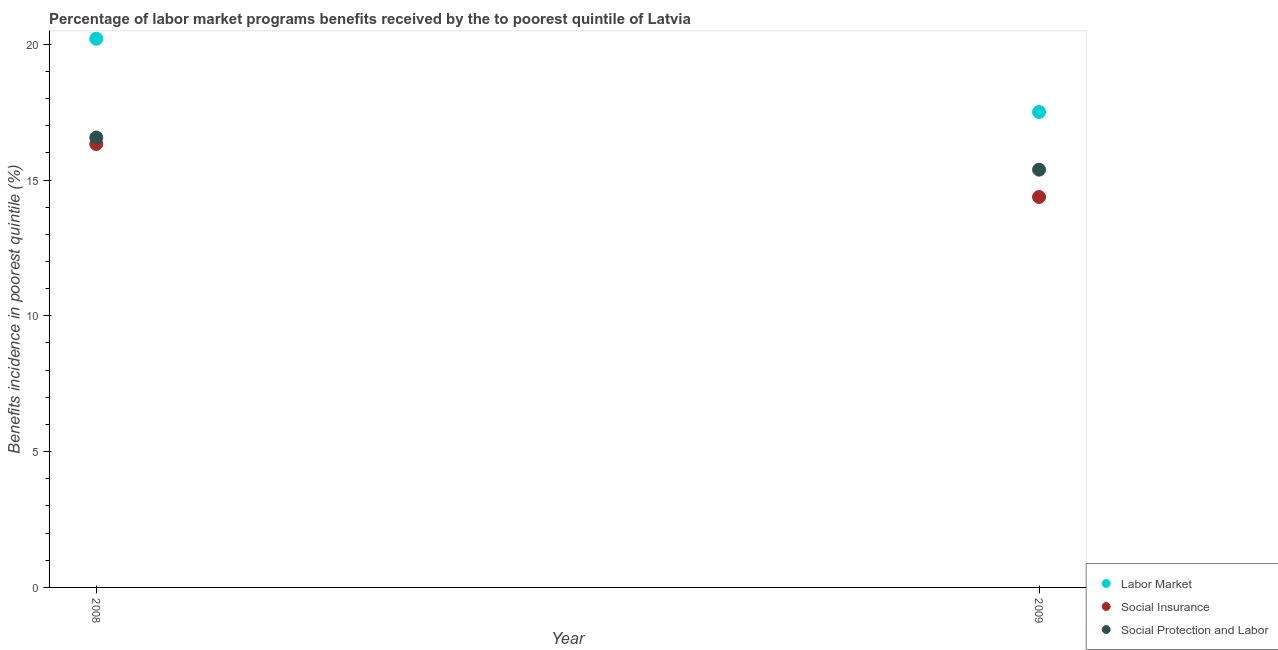How many different coloured dotlines are there?
Keep it short and to the point. 3. Is the number of dotlines equal to the number of legend labels?
Make the answer very short. Yes. What is the percentage of benefits received due to labor market programs in 2009?
Provide a short and direct response. 17.5. Across all years, what is the maximum percentage of benefits received due to labor market programs?
Make the answer very short. 20.2. Across all years, what is the minimum percentage of benefits received due to labor market programs?
Keep it short and to the point. 17.5. In which year was the percentage of benefits received due to social insurance programs maximum?
Offer a very short reply. 2008. What is the total percentage of benefits received due to labor market programs in the graph?
Provide a short and direct response. 37.71. What is the difference between the percentage of benefits received due to social insurance programs in 2008 and that in 2009?
Make the answer very short. 1.95. What is the difference between the percentage of benefits received due to social insurance programs in 2008 and the percentage of benefits received due to social protection programs in 2009?
Ensure brevity in your answer.  0.94. What is the average percentage of benefits received due to labor market programs per year?
Ensure brevity in your answer.  18.85. In the year 2009, what is the difference between the percentage of benefits received due to labor market programs and percentage of benefits received due to social protection programs?
Your answer should be very brief. 2.12. What is the ratio of the percentage of benefits received due to social protection programs in 2008 to that in 2009?
Provide a succinct answer. 1.08. In how many years, is the percentage of benefits received due to social protection programs greater than the average percentage of benefits received due to social protection programs taken over all years?
Offer a terse response. 1. Is it the case that in every year, the sum of the percentage of benefits received due to labor market programs and percentage of benefits received due to social insurance programs is greater than the percentage of benefits received due to social protection programs?
Your answer should be very brief. Yes. How many years are there in the graph?
Offer a very short reply. 2. What is the difference between two consecutive major ticks on the Y-axis?
Your answer should be compact. 5. Are the values on the major ticks of Y-axis written in scientific E-notation?
Your response must be concise. No. Does the graph contain any zero values?
Offer a terse response. No. What is the title of the graph?
Keep it short and to the point. Percentage of labor market programs benefits received by the to poorest quintile of Latvia. Does "Liquid fuel" appear as one of the legend labels in the graph?
Your answer should be compact. No. What is the label or title of the Y-axis?
Your answer should be very brief. Benefits incidence in poorest quintile (%). What is the Benefits incidence in poorest quintile (%) of Labor Market in 2008?
Your answer should be very brief. 20.2. What is the Benefits incidence in poorest quintile (%) in Social Insurance in 2008?
Provide a succinct answer. 16.32. What is the Benefits incidence in poorest quintile (%) in Social Protection and Labor in 2008?
Keep it short and to the point. 16.56. What is the Benefits incidence in poorest quintile (%) of Labor Market in 2009?
Ensure brevity in your answer.  17.5. What is the Benefits incidence in poorest quintile (%) in Social Insurance in 2009?
Your answer should be very brief. 14.38. What is the Benefits incidence in poorest quintile (%) of Social Protection and Labor in 2009?
Offer a very short reply. 15.38. Across all years, what is the maximum Benefits incidence in poorest quintile (%) of Labor Market?
Offer a very short reply. 20.2. Across all years, what is the maximum Benefits incidence in poorest quintile (%) of Social Insurance?
Offer a terse response. 16.32. Across all years, what is the maximum Benefits incidence in poorest quintile (%) of Social Protection and Labor?
Offer a terse response. 16.56. Across all years, what is the minimum Benefits incidence in poorest quintile (%) of Labor Market?
Your answer should be very brief. 17.5. Across all years, what is the minimum Benefits incidence in poorest quintile (%) of Social Insurance?
Make the answer very short. 14.38. Across all years, what is the minimum Benefits incidence in poorest quintile (%) in Social Protection and Labor?
Your answer should be very brief. 15.38. What is the total Benefits incidence in poorest quintile (%) in Labor Market in the graph?
Keep it short and to the point. 37.71. What is the total Benefits incidence in poorest quintile (%) in Social Insurance in the graph?
Offer a very short reply. 30.7. What is the total Benefits incidence in poorest quintile (%) of Social Protection and Labor in the graph?
Give a very brief answer. 31.94. What is the difference between the Benefits incidence in poorest quintile (%) of Labor Market in 2008 and that in 2009?
Your answer should be very brief. 2.7. What is the difference between the Benefits incidence in poorest quintile (%) of Social Insurance in 2008 and that in 2009?
Keep it short and to the point. 1.95. What is the difference between the Benefits incidence in poorest quintile (%) of Social Protection and Labor in 2008 and that in 2009?
Make the answer very short. 1.18. What is the difference between the Benefits incidence in poorest quintile (%) in Labor Market in 2008 and the Benefits incidence in poorest quintile (%) in Social Insurance in 2009?
Your response must be concise. 5.83. What is the difference between the Benefits incidence in poorest quintile (%) in Labor Market in 2008 and the Benefits incidence in poorest quintile (%) in Social Protection and Labor in 2009?
Keep it short and to the point. 4.82. What is the difference between the Benefits incidence in poorest quintile (%) of Social Insurance in 2008 and the Benefits incidence in poorest quintile (%) of Social Protection and Labor in 2009?
Your answer should be very brief. 0.94. What is the average Benefits incidence in poorest quintile (%) of Labor Market per year?
Keep it short and to the point. 18.85. What is the average Benefits incidence in poorest quintile (%) in Social Insurance per year?
Ensure brevity in your answer.  15.35. What is the average Benefits incidence in poorest quintile (%) in Social Protection and Labor per year?
Make the answer very short. 15.97. In the year 2008, what is the difference between the Benefits incidence in poorest quintile (%) in Labor Market and Benefits incidence in poorest quintile (%) in Social Insurance?
Your response must be concise. 3.88. In the year 2008, what is the difference between the Benefits incidence in poorest quintile (%) in Labor Market and Benefits incidence in poorest quintile (%) in Social Protection and Labor?
Offer a terse response. 3.64. In the year 2008, what is the difference between the Benefits incidence in poorest quintile (%) of Social Insurance and Benefits incidence in poorest quintile (%) of Social Protection and Labor?
Ensure brevity in your answer.  -0.24. In the year 2009, what is the difference between the Benefits incidence in poorest quintile (%) of Labor Market and Benefits incidence in poorest quintile (%) of Social Insurance?
Ensure brevity in your answer.  3.13. In the year 2009, what is the difference between the Benefits incidence in poorest quintile (%) of Labor Market and Benefits incidence in poorest quintile (%) of Social Protection and Labor?
Make the answer very short. 2.12. In the year 2009, what is the difference between the Benefits incidence in poorest quintile (%) of Social Insurance and Benefits incidence in poorest quintile (%) of Social Protection and Labor?
Offer a very short reply. -1.01. What is the ratio of the Benefits incidence in poorest quintile (%) in Labor Market in 2008 to that in 2009?
Offer a terse response. 1.15. What is the ratio of the Benefits incidence in poorest quintile (%) of Social Insurance in 2008 to that in 2009?
Your answer should be compact. 1.14. What is the ratio of the Benefits incidence in poorest quintile (%) of Social Protection and Labor in 2008 to that in 2009?
Offer a terse response. 1.08. What is the difference between the highest and the second highest Benefits incidence in poorest quintile (%) of Labor Market?
Ensure brevity in your answer.  2.7. What is the difference between the highest and the second highest Benefits incidence in poorest quintile (%) in Social Insurance?
Offer a terse response. 1.95. What is the difference between the highest and the second highest Benefits incidence in poorest quintile (%) of Social Protection and Labor?
Your answer should be very brief. 1.18. What is the difference between the highest and the lowest Benefits incidence in poorest quintile (%) in Labor Market?
Provide a short and direct response. 2.7. What is the difference between the highest and the lowest Benefits incidence in poorest quintile (%) in Social Insurance?
Your answer should be very brief. 1.95. What is the difference between the highest and the lowest Benefits incidence in poorest quintile (%) in Social Protection and Labor?
Give a very brief answer. 1.18. 